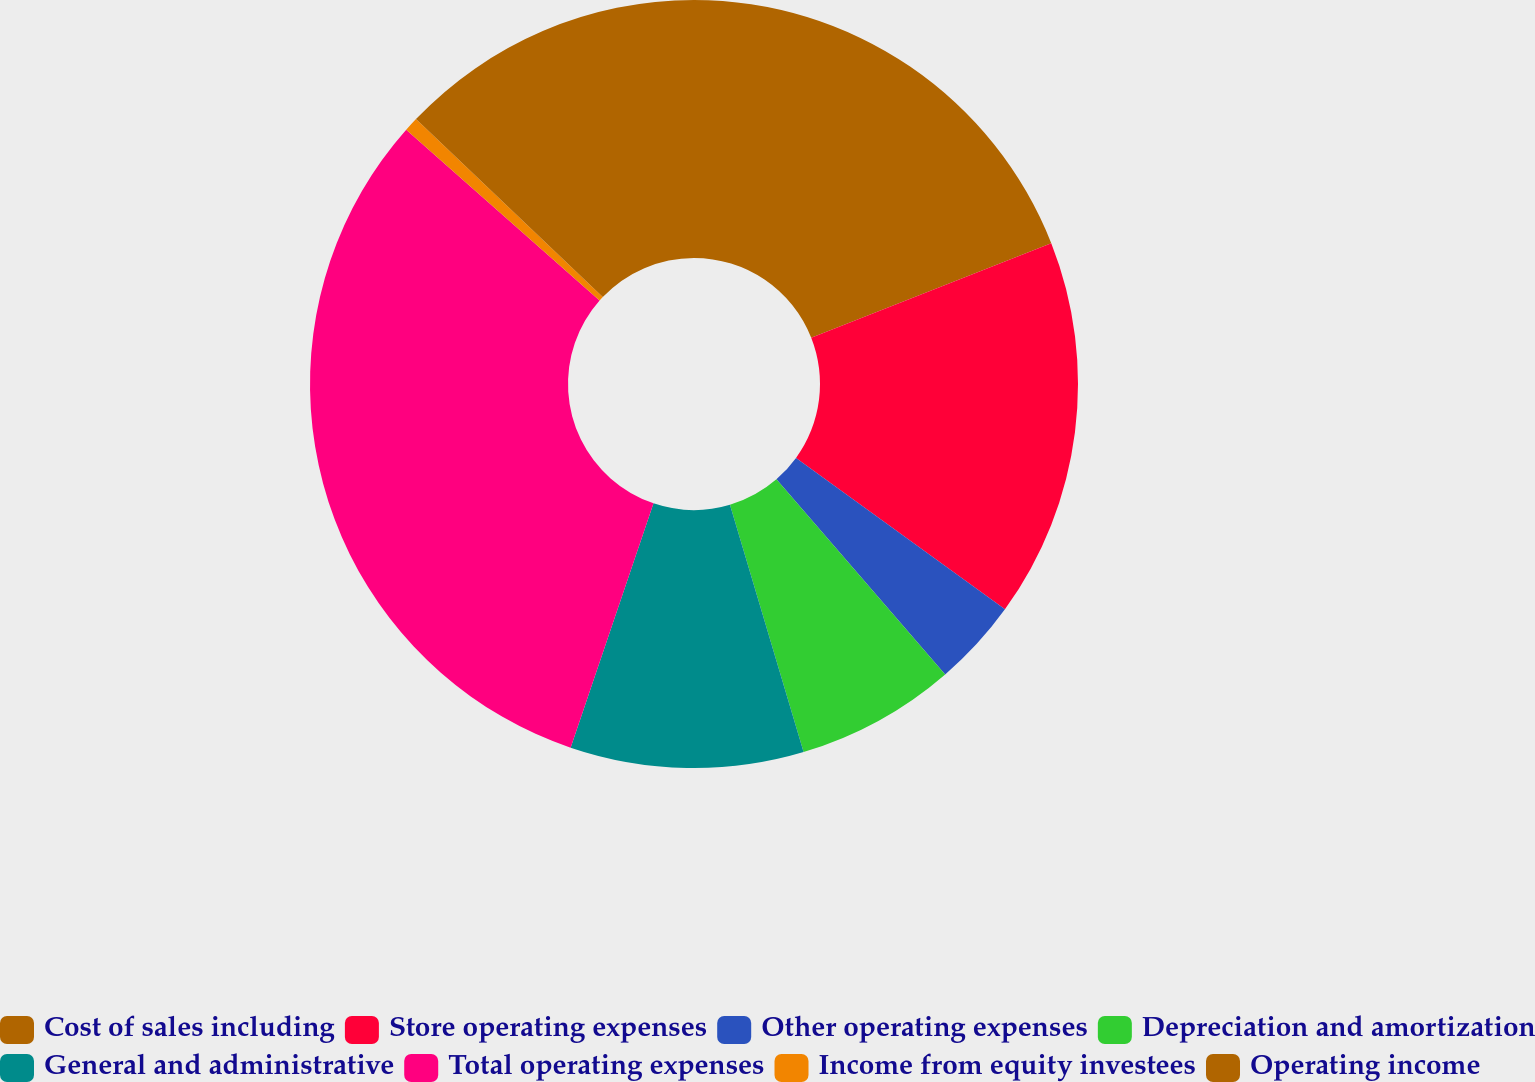Convert chart. <chart><loc_0><loc_0><loc_500><loc_500><pie_chart><fcel>Cost of sales including<fcel>Store operating expenses<fcel>Other operating expenses<fcel>Depreciation and amortization<fcel>General and administrative<fcel>Total operating expenses<fcel>Income from equity investees<fcel>Operating income<nl><fcel>19.02%<fcel>15.95%<fcel>3.67%<fcel>6.74%<fcel>9.81%<fcel>31.3%<fcel>0.6%<fcel>12.88%<nl></chart> 